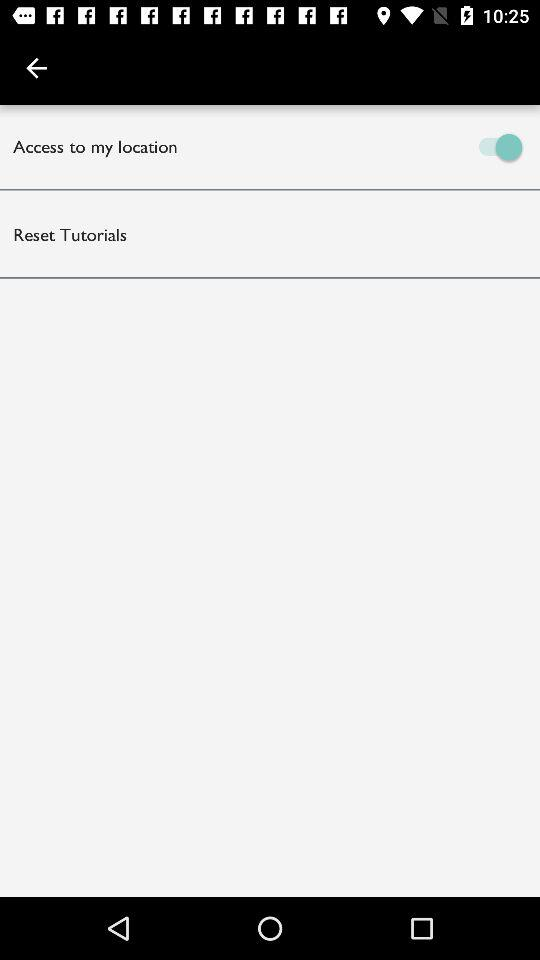What is the status of "Access to my location"? The status is "on". 